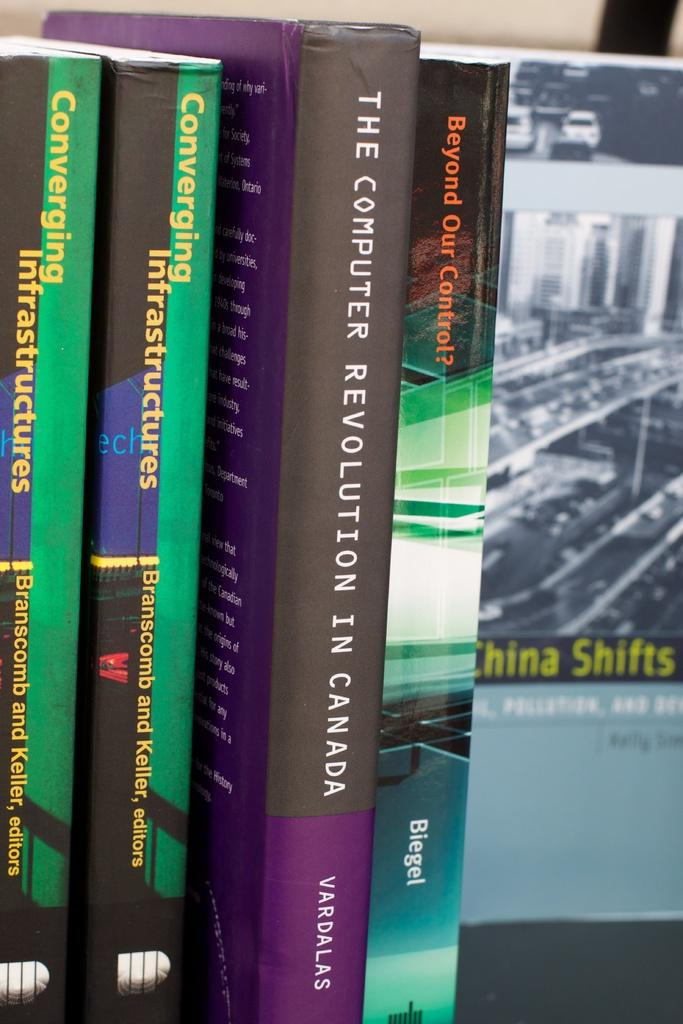What objects can be seen in the image? There are books in the image. What is visible on the books? There is writing on the books. What type of underwear is being smashed by the books in the image? There is no underwear or smashing present in the image; it only features books with writing on them. 